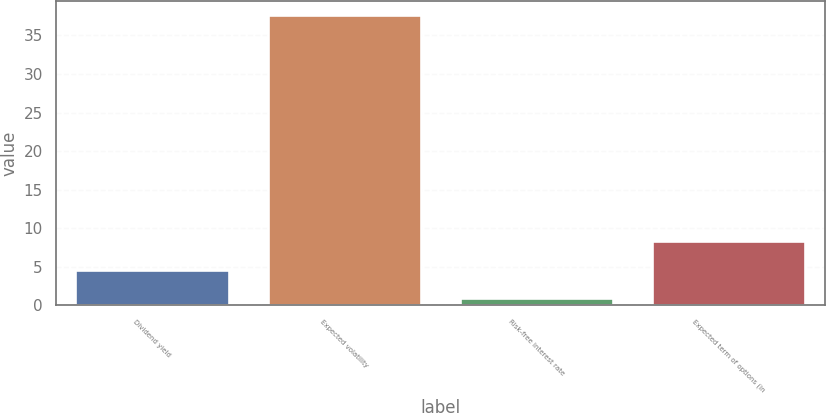<chart> <loc_0><loc_0><loc_500><loc_500><bar_chart><fcel>Dividend yield<fcel>Expected volatility<fcel>Risk-free interest rate<fcel>Expected term of options (in<nl><fcel>4.62<fcel>37.65<fcel>0.95<fcel>8.29<nl></chart> 